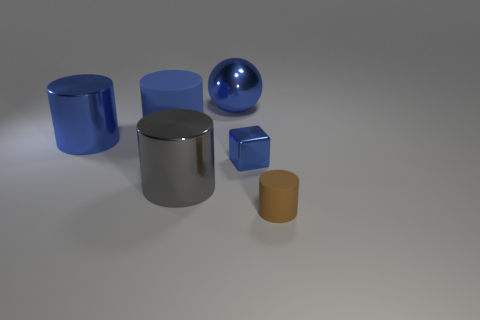Subtract all large blue metallic cylinders. How many cylinders are left? 3 Subtract all blue cylinders. How many cylinders are left? 2 Add 4 tiny brown cylinders. How many objects exist? 10 Subtract all cylinders. How many objects are left? 2 Subtract 1 balls. How many balls are left? 0 Subtract all green balls. Subtract all green blocks. How many balls are left? 1 Subtract all purple spheres. How many blue cylinders are left? 2 Subtract all large gray things. Subtract all large blue matte objects. How many objects are left? 4 Add 3 tiny blue metal things. How many tiny blue metal things are left? 4 Add 6 big cyan rubber balls. How many big cyan rubber balls exist? 6 